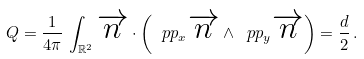Convert formula to latex. <formula><loc_0><loc_0><loc_500><loc_500>Q = \frac { 1 } { 4 \pi } \, \int _ { \mathbb { R } ^ { 2 } } \overrightarrow { n } \cdot \left ( \ p p _ { x } \overrightarrow { n } \wedge \ p p _ { y } \overrightarrow { n } \right ) = \frac { d } { 2 } \, .</formula> 